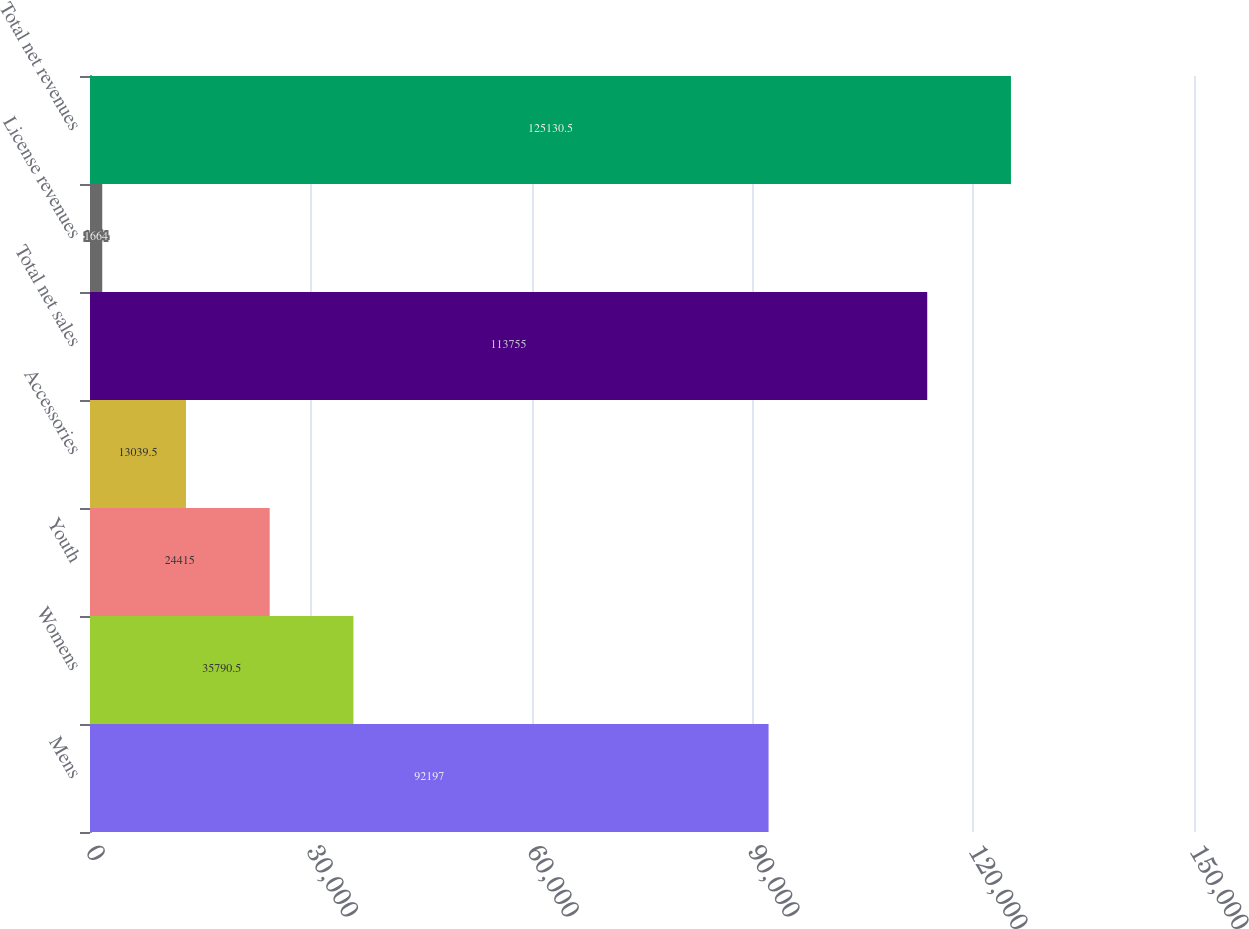Convert chart. <chart><loc_0><loc_0><loc_500><loc_500><bar_chart><fcel>Mens<fcel>Womens<fcel>Youth<fcel>Accessories<fcel>Total net sales<fcel>License revenues<fcel>Total net revenues<nl><fcel>92197<fcel>35790.5<fcel>24415<fcel>13039.5<fcel>113755<fcel>1664<fcel>125130<nl></chart> 